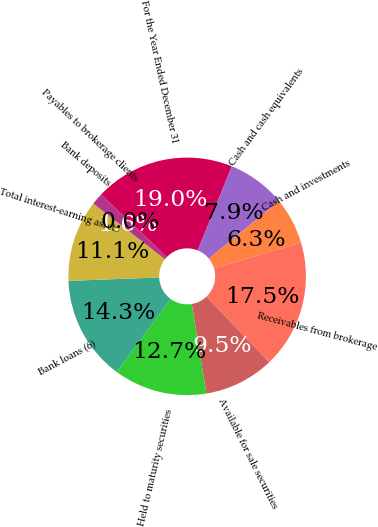Convert chart. <chart><loc_0><loc_0><loc_500><loc_500><pie_chart><fcel>For the Year Ended December 31<fcel>Cash and cash equivalents<fcel>Cash and investments<fcel>Receivables from brokerage<fcel>Available for sale securities<fcel>Held to maturity securities<fcel>Bank loans (6)<fcel>Total interest-earning assets<fcel>Bank deposits<fcel>Payables to brokerage clients<nl><fcel>19.05%<fcel>7.94%<fcel>6.35%<fcel>17.46%<fcel>9.52%<fcel>12.7%<fcel>14.29%<fcel>11.11%<fcel>1.59%<fcel>0.0%<nl></chart> 